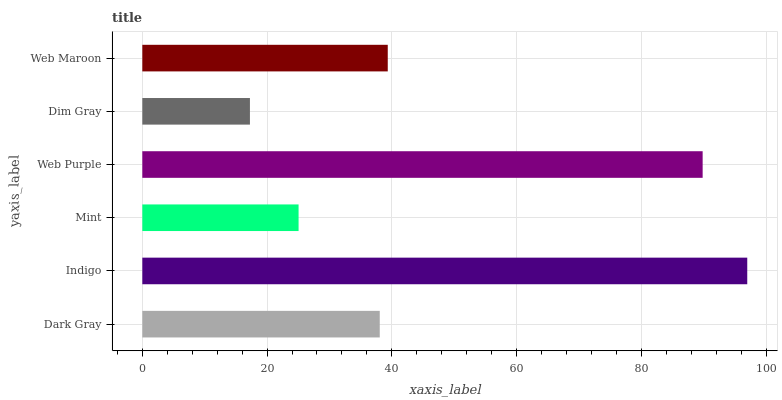Is Dim Gray the minimum?
Answer yes or no. Yes. Is Indigo the maximum?
Answer yes or no. Yes. Is Mint the minimum?
Answer yes or no. No. Is Mint the maximum?
Answer yes or no. No. Is Indigo greater than Mint?
Answer yes or no. Yes. Is Mint less than Indigo?
Answer yes or no. Yes. Is Mint greater than Indigo?
Answer yes or no. No. Is Indigo less than Mint?
Answer yes or no. No. Is Web Maroon the high median?
Answer yes or no. Yes. Is Dark Gray the low median?
Answer yes or no. Yes. Is Indigo the high median?
Answer yes or no. No. Is Dim Gray the low median?
Answer yes or no. No. 